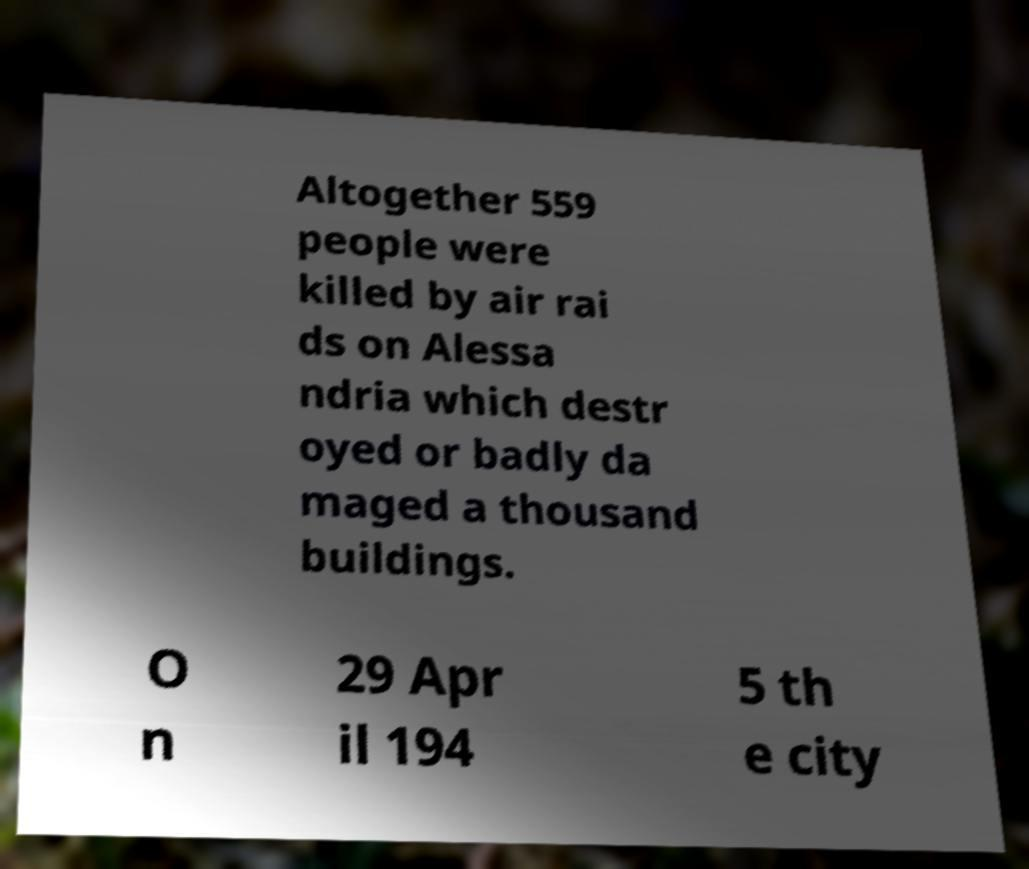Please identify and transcribe the text found in this image. Altogether 559 people were killed by air rai ds on Alessa ndria which destr oyed or badly da maged a thousand buildings. O n 29 Apr il 194 5 th e city 